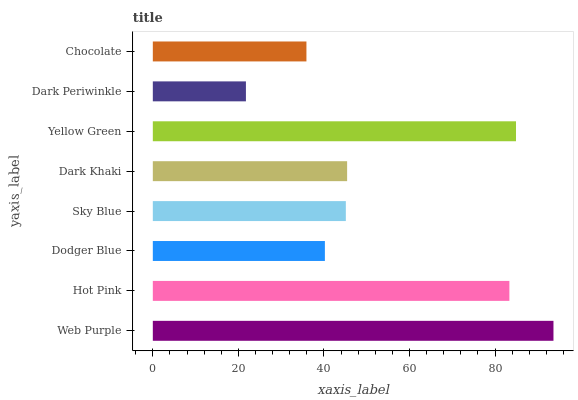Is Dark Periwinkle the minimum?
Answer yes or no. Yes. Is Web Purple the maximum?
Answer yes or no. Yes. Is Hot Pink the minimum?
Answer yes or no. No. Is Hot Pink the maximum?
Answer yes or no. No. Is Web Purple greater than Hot Pink?
Answer yes or no. Yes. Is Hot Pink less than Web Purple?
Answer yes or no. Yes. Is Hot Pink greater than Web Purple?
Answer yes or no. No. Is Web Purple less than Hot Pink?
Answer yes or no. No. Is Dark Khaki the high median?
Answer yes or no. Yes. Is Sky Blue the low median?
Answer yes or no. Yes. Is Dodger Blue the high median?
Answer yes or no. No. Is Web Purple the low median?
Answer yes or no. No. 